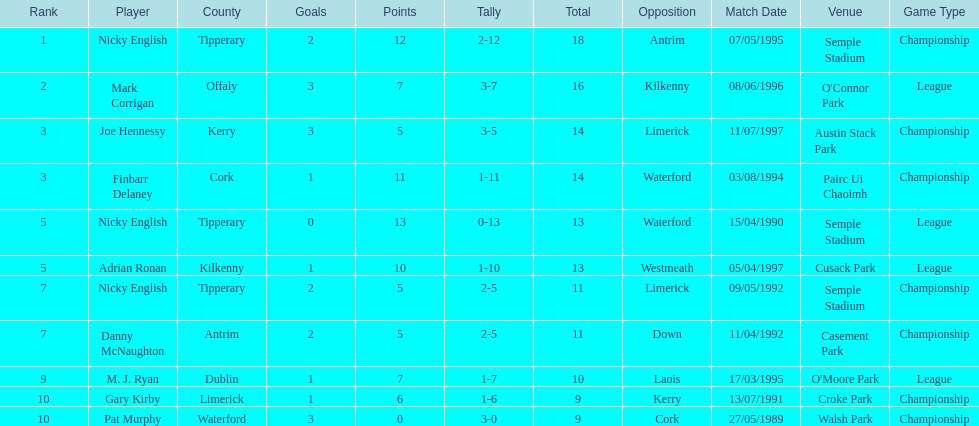Joe hennessy and finbarr delaney both scored how many points? 14. 